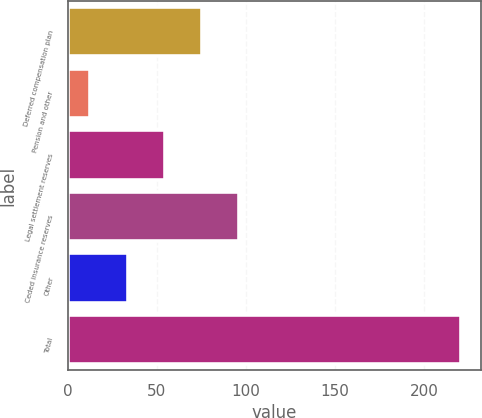<chart> <loc_0><loc_0><loc_500><loc_500><bar_chart><fcel>Deferred compensation plan<fcel>Pension and other<fcel>Legal settlement reserves<fcel>Ceded insurance reserves<fcel>Other<fcel>Total<nl><fcel>75.16<fcel>12.7<fcel>54.34<fcel>95.98<fcel>33.52<fcel>220.9<nl></chart> 